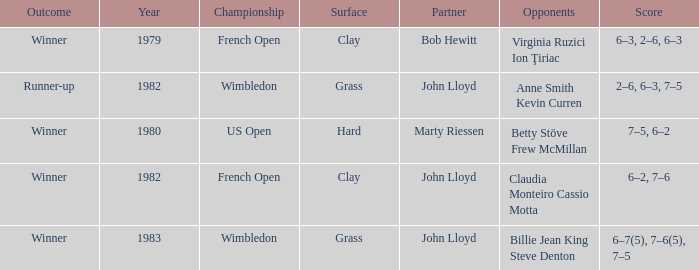What was the surface for events held in 1983? Grass. 